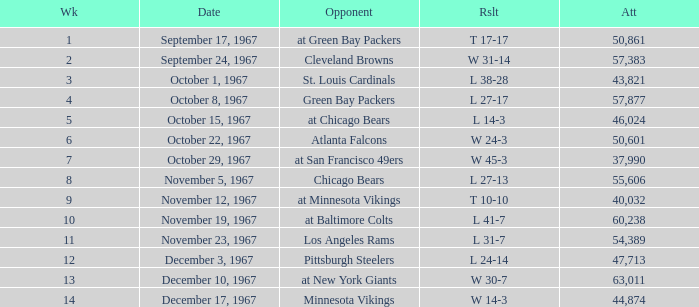Which Date has a Week smaller than 8, and an Opponent of atlanta falcons? October 22, 1967. 